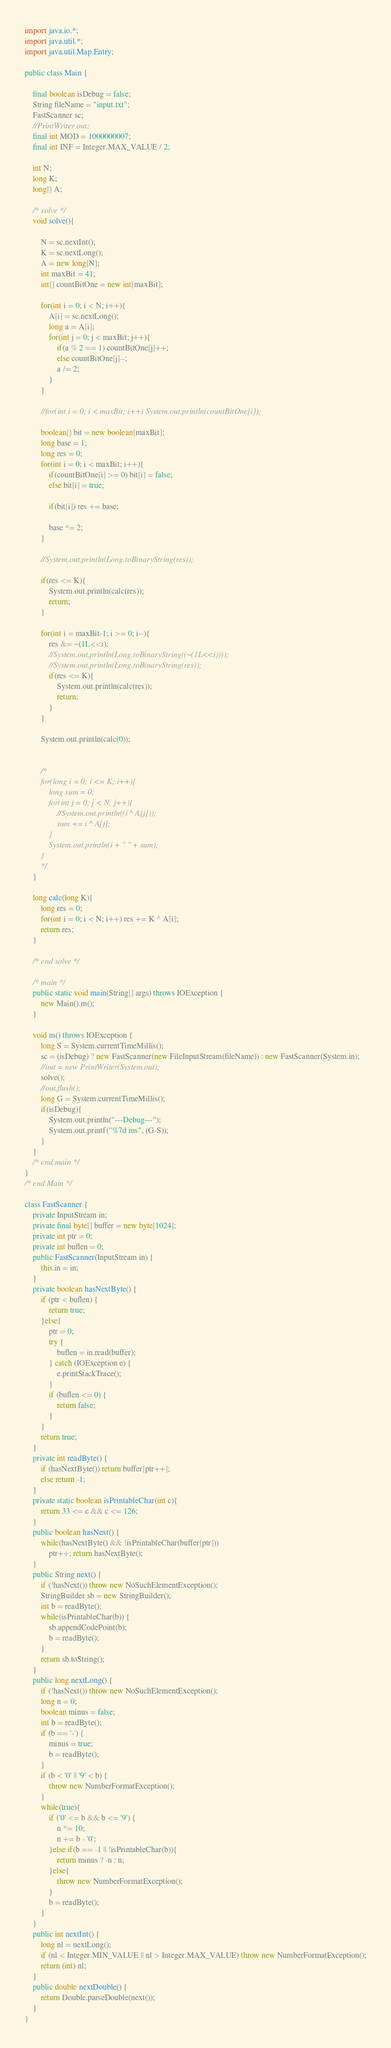Convert code to text. <code><loc_0><loc_0><loc_500><loc_500><_Java_>import java.io.*;
import java.util.*;
import java.util.Map.Entry;

public class Main {
	
	final boolean isDebug = false;
	String fileName = "input.txt";
	FastScanner sc;
	//PrintWriter out;
	final int MOD = 1000000007;
	final int INF = Integer.MAX_VALUE / 2;
	
	int N;
	long K;
	long[] A;
	
	/* solve */
	void solve(){
		
		N = sc.nextInt();
		K = sc.nextLong();
		A = new long[N];
		int maxBit = 41;
		int[] countBitOne = new int[maxBit];
		
		for(int i = 0; i < N; i++){
			A[i] = sc.nextLong();
			long a = A[i];
			for(int j = 0; j < maxBit; j++){
				if(a % 2 == 1) countBitOne[j]++;
				else countBitOne[j]--;
				a /= 2;
			}
		}
		
		//for(int i = 0; i < maxBit; i++) System.out.println(countBitOne[i]);
		
		boolean[] bit = new boolean[maxBit];
		long base = 1;
		long res = 0;
		for(int i = 0; i < maxBit; i++){
			if(countBitOne[i] >= 0) bit[i] = false;
			else bit[i] = true;
			
			if(bit[i]) res += base;
			
			base *= 2;
		}
		
		//System.out.println(Long.toBinaryString(res));
		
		if(res <= K){
			System.out.println(calc(res));
			return;
		}
		
		for(int i = maxBit-1; i >= 0; i--){
			res &= ~(1L<<i);
			//System.out.println(Long.toBinaryString((~(1L<<i))));
			//System.out.println(Long.toBinaryString(res));
			if(res <= K){
				System.out.println(calc(res));
				return;
			}
		}
		
		System.out.println(calc(0));
		
		
		/*
		for(long i = 0; i <= K; i++){
			long sum = 0;
			for(int j = 0; j < N; j++){
				//System.out.println((i ^ A[j]));
				sum += i ^ A[j];
			}
			System.out.println(i + " " + sum);
		}
		*/
	}
	
	long calc(long K){
		long res = 0;
		for(int i = 0; i < N; i++) res += K ^ A[i];
		return res;
	}
	
	/* end solve */
	
	/* main */
	public static void main(String[] args) throws IOException {
		new Main().m();
	}
	
	void m() throws IOException {
		long S = System.currentTimeMillis();
		sc = (isDebug) ? new FastScanner(new FileInputStream(fileName)) : new FastScanner(System.in);
		//out = new PrintWriter(System.out);
		solve();
		//out.flush();
		long G = System.currentTimeMillis();
		if(isDebug){
			System.out.println("---Debug---");
			System.out.printf("%7d ms", (G-S));
		}
	}
	/* end main */
}
/* end Main */

class FastScanner {
    private InputStream in;
    private final byte[] buffer = new byte[1024];
    private int ptr = 0;
    private int buflen = 0;
    public FastScanner(InputStream in) {
		this.in = in;
	}
    private boolean hasNextByte() {
        if (ptr < buflen) {
            return true;
        }else{
            ptr = 0;
            try {
                buflen = in.read(buffer);
            } catch (IOException e) {
                e.printStackTrace();
            }
            if (buflen <= 0) {
                return false;
            }
        }
        return true;
    }
    private int readByte() {
    	if (hasNextByte()) return buffer[ptr++];
    	else return -1;
    }
    private static boolean isPrintableChar(int c){
    	return 33 <= c && c <= 126;
    }
    public boolean hasNext() {
    	while(hasNextByte() && !isPrintableChar(buffer[ptr]))
    		ptr++; return hasNextByte();
    }
    public String next() {
        if (!hasNext()) throw new NoSuchElementException();
        StringBuilder sb = new StringBuilder();
        int b = readByte();
        while(isPrintableChar(b)) {
            sb.appendCodePoint(b);
            b = readByte();
        }
        return sb.toString();
    }
    public long nextLong() {
        if (!hasNext()) throw new NoSuchElementException();
        long n = 0;
        boolean minus = false;
        int b = readByte();
        if (b == '-') {
            minus = true;
            b = readByte();
        }
        if (b < '0' || '9' < b) {
            throw new NumberFormatException();
        }
        while(true){
            if ('0' <= b && b <= '9') {
                n *= 10;
                n += b - '0';
            }else if(b == -1 || !isPrintableChar(b)){
                return minus ? -n : n;
            }else{
                throw new NumberFormatException();
            }
            b = readByte();
        }
    }
    public int nextInt() {
        long nl = nextLong();
        if (nl < Integer.MIN_VALUE || nl > Integer.MAX_VALUE) throw new NumberFormatException();
        return (int) nl;
    }
    public double nextDouble() {
    	return Double.parseDouble(next());
    }
}
</code> 